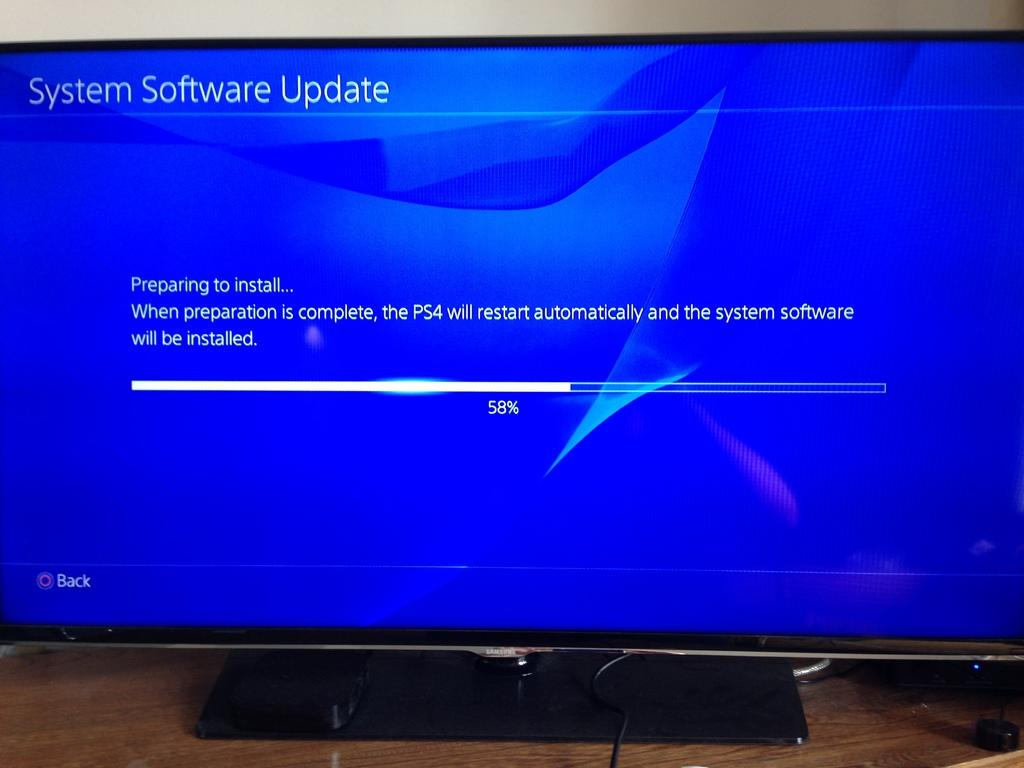<image>
Describe the image concisely. A screen is displaying update information for a PS4. 